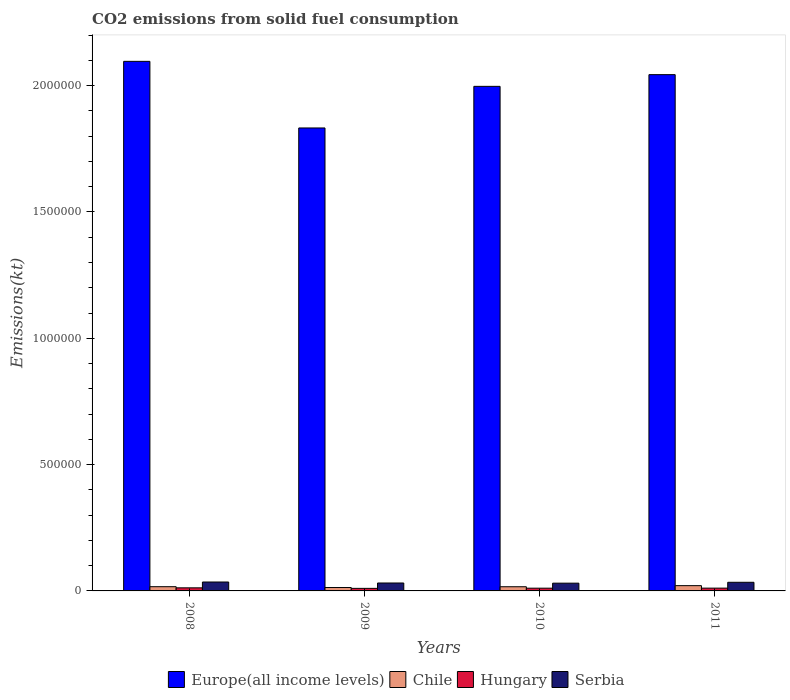How many different coloured bars are there?
Offer a very short reply. 4. How many groups of bars are there?
Ensure brevity in your answer.  4. Are the number of bars per tick equal to the number of legend labels?
Provide a short and direct response. Yes. How many bars are there on the 3rd tick from the left?
Provide a short and direct response. 4. How many bars are there on the 2nd tick from the right?
Give a very brief answer. 4. In how many cases, is the number of bars for a given year not equal to the number of legend labels?
Your response must be concise. 0. What is the amount of CO2 emitted in Chile in 2011?
Your answer should be very brief. 2.09e+04. Across all years, what is the maximum amount of CO2 emitted in Hungary?
Ensure brevity in your answer.  1.22e+04. Across all years, what is the minimum amount of CO2 emitted in Europe(all income levels)?
Offer a terse response. 1.83e+06. What is the total amount of CO2 emitted in Hungary in the graph?
Offer a very short reply. 4.41e+04. What is the difference between the amount of CO2 emitted in Serbia in 2010 and that in 2011?
Provide a succinct answer. -3501.98. What is the difference between the amount of CO2 emitted in Chile in 2010 and the amount of CO2 emitted in Hungary in 2009?
Give a very brief answer. 6461.25. What is the average amount of CO2 emitted in Hungary per year?
Offer a terse response. 1.10e+04. In the year 2009, what is the difference between the amount of CO2 emitted in Europe(all income levels) and amount of CO2 emitted in Serbia?
Keep it short and to the point. 1.80e+06. In how many years, is the amount of CO2 emitted in Chile greater than 900000 kt?
Provide a short and direct response. 0. What is the ratio of the amount of CO2 emitted in Europe(all income levels) in 2008 to that in 2010?
Make the answer very short. 1.05. Is the amount of CO2 emitted in Europe(all income levels) in 2009 less than that in 2011?
Provide a short and direct response. Yes. Is the difference between the amount of CO2 emitted in Europe(all income levels) in 2008 and 2010 greater than the difference between the amount of CO2 emitted in Serbia in 2008 and 2010?
Provide a succinct answer. Yes. What is the difference between the highest and the second highest amount of CO2 emitted in Serbia?
Your response must be concise. 1118.43. What is the difference between the highest and the lowest amount of CO2 emitted in Hungary?
Your answer should be compact. 2108.52. What does the 2nd bar from the right in 2008 represents?
Offer a terse response. Hungary. How many bars are there?
Offer a terse response. 16. How many years are there in the graph?
Your answer should be very brief. 4. What is the difference between two consecutive major ticks on the Y-axis?
Provide a succinct answer. 5.00e+05. Are the values on the major ticks of Y-axis written in scientific E-notation?
Keep it short and to the point. No. Does the graph contain grids?
Ensure brevity in your answer.  No. How many legend labels are there?
Offer a terse response. 4. What is the title of the graph?
Give a very brief answer. CO2 emissions from solid fuel consumption. What is the label or title of the Y-axis?
Your response must be concise. Emissions(kt). What is the Emissions(kt) in Europe(all income levels) in 2008?
Provide a short and direct response. 2.10e+06. What is the Emissions(kt) in Chile in 2008?
Your answer should be very brief. 1.67e+04. What is the Emissions(kt) of Hungary in 2008?
Give a very brief answer. 1.22e+04. What is the Emissions(kt) in Serbia in 2008?
Your answer should be very brief. 3.53e+04. What is the Emissions(kt) in Europe(all income levels) in 2009?
Make the answer very short. 1.83e+06. What is the Emissions(kt) in Chile in 2009?
Give a very brief answer. 1.34e+04. What is the Emissions(kt) of Hungary in 2009?
Provide a succinct answer. 1.01e+04. What is the Emissions(kt) of Serbia in 2009?
Your answer should be very brief. 3.14e+04. What is the Emissions(kt) in Europe(all income levels) in 2010?
Provide a succinct answer. 2.00e+06. What is the Emissions(kt) of Chile in 2010?
Your response must be concise. 1.65e+04. What is the Emissions(kt) in Hungary in 2010?
Your answer should be very brief. 1.08e+04. What is the Emissions(kt) of Serbia in 2010?
Your answer should be compact. 3.07e+04. What is the Emissions(kt) of Europe(all income levels) in 2011?
Offer a terse response. 2.04e+06. What is the Emissions(kt) in Chile in 2011?
Offer a very short reply. 2.09e+04. What is the Emissions(kt) of Hungary in 2011?
Offer a terse response. 1.10e+04. What is the Emissions(kt) in Serbia in 2011?
Keep it short and to the point. 3.42e+04. Across all years, what is the maximum Emissions(kt) in Europe(all income levels)?
Offer a terse response. 2.10e+06. Across all years, what is the maximum Emissions(kt) in Chile?
Your answer should be very brief. 2.09e+04. Across all years, what is the maximum Emissions(kt) of Hungary?
Provide a short and direct response. 1.22e+04. Across all years, what is the maximum Emissions(kt) in Serbia?
Your response must be concise. 3.53e+04. Across all years, what is the minimum Emissions(kt) of Europe(all income levels)?
Your answer should be very brief. 1.83e+06. Across all years, what is the minimum Emissions(kt) of Chile?
Your response must be concise. 1.34e+04. Across all years, what is the minimum Emissions(kt) of Hungary?
Offer a terse response. 1.01e+04. Across all years, what is the minimum Emissions(kt) of Serbia?
Ensure brevity in your answer.  3.07e+04. What is the total Emissions(kt) in Europe(all income levels) in the graph?
Your response must be concise. 7.97e+06. What is the total Emissions(kt) of Chile in the graph?
Give a very brief answer. 6.76e+04. What is the total Emissions(kt) of Hungary in the graph?
Keep it short and to the point. 4.41e+04. What is the total Emissions(kt) in Serbia in the graph?
Offer a very short reply. 1.32e+05. What is the difference between the Emissions(kt) of Europe(all income levels) in 2008 and that in 2009?
Your answer should be compact. 2.64e+05. What is the difference between the Emissions(kt) of Chile in 2008 and that in 2009?
Ensure brevity in your answer.  3303.97. What is the difference between the Emissions(kt) in Hungary in 2008 and that in 2009?
Offer a very short reply. 2108.53. What is the difference between the Emissions(kt) of Serbia in 2008 and that in 2009?
Make the answer very short. 3938.36. What is the difference between the Emissions(kt) of Europe(all income levels) in 2008 and that in 2010?
Provide a succinct answer. 9.89e+04. What is the difference between the Emissions(kt) of Chile in 2008 and that in 2010?
Your answer should be compact. 198.02. What is the difference between the Emissions(kt) of Hungary in 2008 and that in 2010?
Offer a terse response. 1349.46. What is the difference between the Emissions(kt) in Serbia in 2008 and that in 2010?
Make the answer very short. 4620.42. What is the difference between the Emissions(kt) in Europe(all income levels) in 2008 and that in 2011?
Give a very brief answer. 5.26e+04. What is the difference between the Emissions(kt) in Chile in 2008 and that in 2011?
Your answer should be compact. -4110.71. What is the difference between the Emissions(kt) of Hungary in 2008 and that in 2011?
Provide a succinct answer. 1180.77. What is the difference between the Emissions(kt) of Serbia in 2008 and that in 2011?
Give a very brief answer. 1118.43. What is the difference between the Emissions(kt) in Europe(all income levels) in 2009 and that in 2010?
Provide a succinct answer. -1.65e+05. What is the difference between the Emissions(kt) in Chile in 2009 and that in 2010?
Ensure brevity in your answer.  -3105.95. What is the difference between the Emissions(kt) in Hungary in 2009 and that in 2010?
Provide a succinct answer. -759.07. What is the difference between the Emissions(kt) in Serbia in 2009 and that in 2010?
Your answer should be compact. 682.06. What is the difference between the Emissions(kt) of Europe(all income levels) in 2009 and that in 2011?
Keep it short and to the point. -2.11e+05. What is the difference between the Emissions(kt) of Chile in 2009 and that in 2011?
Offer a terse response. -7414.67. What is the difference between the Emissions(kt) of Hungary in 2009 and that in 2011?
Keep it short and to the point. -927.75. What is the difference between the Emissions(kt) of Serbia in 2009 and that in 2011?
Offer a very short reply. -2819.92. What is the difference between the Emissions(kt) in Europe(all income levels) in 2010 and that in 2011?
Keep it short and to the point. -4.63e+04. What is the difference between the Emissions(kt) in Chile in 2010 and that in 2011?
Offer a terse response. -4308.73. What is the difference between the Emissions(kt) in Hungary in 2010 and that in 2011?
Give a very brief answer. -168.68. What is the difference between the Emissions(kt) of Serbia in 2010 and that in 2011?
Offer a very short reply. -3501.99. What is the difference between the Emissions(kt) of Europe(all income levels) in 2008 and the Emissions(kt) of Chile in 2009?
Your answer should be compact. 2.08e+06. What is the difference between the Emissions(kt) in Europe(all income levels) in 2008 and the Emissions(kt) in Hungary in 2009?
Your answer should be compact. 2.09e+06. What is the difference between the Emissions(kt) in Europe(all income levels) in 2008 and the Emissions(kt) in Serbia in 2009?
Make the answer very short. 2.06e+06. What is the difference between the Emissions(kt) of Chile in 2008 and the Emissions(kt) of Hungary in 2009?
Make the answer very short. 6659.27. What is the difference between the Emissions(kt) in Chile in 2008 and the Emissions(kt) in Serbia in 2009?
Ensure brevity in your answer.  -1.46e+04. What is the difference between the Emissions(kt) in Hungary in 2008 and the Emissions(kt) in Serbia in 2009?
Offer a terse response. -1.92e+04. What is the difference between the Emissions(kt) in Europe(all income levels) in 2008 and the Emissions(kt) in Chile in 2010?
Your answer should be compact. 2.08e+06. What is the difference between the Emissions(kt) of Europe(all income levels) in 2008 and the Emissions(kt) of Hungary in 2010?
Make the answer very short. 2.09e+06. What is the difference between the Emissions(kt) of Europe(all income levels) in 2008 and the Emissions(kt) of Serbia in 2010?
Offer a very short reply. 2.07e+06. What is the difference between the Emissions(kt) in Chile in 2008 and the Emissions(kt) in Hungary in 2010?
Your response must be concise. 5900.2. What is the difference between the Emissions(kt) of Chile in 2008 and the Emissions(kt) of Serbia in 2010?
Your response must be concise. -1.39e+04. What is the difference between the Emissions(kt) in Hungary in 2008 and the Emissions(kt) in Serbia in 2010?
Your answer should be very brief. -1.85e+04. What is the difference between the Emissions(kt) in Europe(all income levels) in 2008 and the Emissions(kt) in Chile in 2011?
Give a very brief answer. 2.08e+06. What is the difference between the Emissions(kt) in Europe(all income levels) in 2008 and the Emissions(kt) in Hungary in 2011?
Ensure brevity in your answer.  2.09e+06. What is the difference between the Emissions(kt) of Europe(all income levels) in 2008 and the Emissions(kt) of Serbia in 2011?
Keep it short and to the point. 2.06e+06. What is the difference between the Emissions(kt) of Chile in 2008 and the Emissions(kt) of Hungary in 2011?
Your response must be concise. 5731.52. What is the difference between the Emissions(kt) of Chile in 2008 and the Emissions(kt) of Serbia in 2011?
Ensure brevity in your answer.  -1.74e+04. What is the difference between the Emissions(kt) of Hungary in 2008 and the Emissions(kt) of Serbia in 2011?
Provide a short and direct response. -2.20e+04. What is the difference between the Emissions(kt) of Europe(all income levels) in 2009 and the Emissions(kt) of Chile in 2010?
Ensure brevity in your answer.  1.82e+06. What is the difference between the Emissions(kt) of Europe(all income levels) in 2009 and the Emissions(kt) of Hungary in 2010?
Your answer should be compact. 1.82e+06. What is the difference between the Emissions(kt) of Europe(all income levels) in 2009 and the Emissions(kt) of Serbia in 2010?
Ensure brevity in your answer.  1.80e+06. What is the difference between the Emissions(kt) in Chile in 2009 and the Emissions(kt) in Hungary in 2010?
Give a very brief answer. 2596.24. What is the difference between the Emissions(kt) in Chile in 2009 and the Emissions(kt) in Serbia in 2010?
Make the answer very short. -1.72e+04. What is the difference between the Emissions(kt) in Hungary in 2009 and the Emissions(kt) in Serbia in 2010?
Make the answer very short. -2.06e+04. What is the difference between the Emissions(kt) of Europe(all income levels) in 2009 and the Emissions(kt) of Chile in 2011?
Make the answer very short. 1.81e+06. What is the difference between the Emissions(kt) of Europe(all income levels) in 2009 and the Emissions(kt) of Hungary in 2011?
Give a very brief answer. 1.82e+06. What is the difference between the Emissions(kt) in Europe(all income levels) in 2009 and the Emissions(kt) in Serbia in 2011?
Provide a succinct answer. 1.80e+06. What is the difference between the Emissions(kt) of Chile in 2009 and the Emissions(kt) of Hungary in 2011?
Provide a succinct answer. 2427.55. What is the difference between the Emissions(kt) in Chile in 2009 and the Emissions(kt) in Serbia in 2011?
Your answer should be very brief. -2.07e+04. What is the difference between the Emissions(kt) in Hungary in 2009 and the Emissions(kt) in Serbia in 2011?
Your response must be concise. -2.41e+04. What is the difference between the Emissions(kt) of Europe(all income levels) in 2010 and the Emissions(kt) of Chile in 2011?
Make the answer very short. 1.98e+06. What is the difference between the Emissions(kt) of Europe(all income levels) in 2010 and the Emissions(kt) of Hungary in 2011?
Offer a very short reply. 1.99e+06. What is the difference between the Emissions(kt) of Europe(all income levels) in 2010 and the Emissions(kt) of Serbia in 2011?
Give a very brief answer. 1.96e+06. What is the difference between the Emissions(kt) of Chile in 2010 and the Emissions(kt) of Hungary in 2011?
Provide a succinct answer. 5533.5. What is the difference between the Emissions(kt) in Chile in 2010 and the Emissions(kt) in Serbia in 2011?
Your answer should be very brief. -1.76e+04. What is the difference between the Emissions(kt) of Hungary in 2010 and the Emissions(kt) of Serbia in 2011?
Make the answer very short. -2.33e+04. What is the average Emissions(kt) in Europe(all income levels) per year?
Offer a terse response. 1.99e+06. What is the average Emissions(kt) of Chile per year?
Offer a terse response. 1.69e+04. What is the average Emissions(kt) in Hungary per year?
Your response must be concise. 1.10e+04. What is the average Emissions(kt) of Serbia per year?
Your response must be concise. 3.29e+04. In the year 2008, what is the difference between the Emissions(kt) in Europe(all income levels) and Emissions(kt) in Chile?
Provide a succinct answer. 2.08e+06. In the year 2008, what is the difference between the Emissions(kt) in Europe(all income levels) and Emissions(kt) in Hungary?
Offer a very short reply. 2.08e+06. In the year 2008, what is the difference between the Emissions(kt) in Europe(all income levels) and Emissions(kt) in Serbia?
Offer a very short reply. 2.06e+06. In the year 2008, what is the difference between the Emissions(kt) in Chile and Emissions(kt) in Hungary?
Keep it short and to the point. 4550.75. In the year 2008, what is the difference between the Emissions(kt) of Chile and Emissions(kt) of Serbia?
Offer a terse response. -1.86e+04. In the year 2008, what is the difference between the Emissions(kt) in Hungary and Emissions(kt) in Serbia?
Offer a terse response. -2.31e+04. In the year 2009, what is the difference between the Emissions(kt) of Europe(all income levels) and Emissions(kt) of Chile?
Your answer should be very brief. 1.82e+06. In the year 2009, what is the difference between the Emissions(kt) in Europe(all income levels) and Emissions(kt) in Hungary?
Give a very brief answer. 1.82e+06. In the year 2009, what is the difference between the Emissions(kt) of Europe(all income levels) and Emissions(kt) of Serbia?
Your response must be concise. 1.80e+06. In the year 2009, what is the difference between the Emissions(kt) in Chile and Emissions(kt) in Hungary?
Offer a terse response. 3355.3. In the year 2009, what is the difference between the Emissions(kt) in Chile and Emissions(kt) in Serbia?
Provide a succinct answer. -1.79e+04. In the year 2009, what is the difference between the Emissions(kt) of Hungary and Emissions(kt) of Serbia?
Offer a terse response. -2.13e+04. In the year 2010, what is the difference between the Emissions(kt) of Europe(all income levels) and Emissions(kt) of Chile?
Your answer should be very brief. 1.98e+06. In the year 2010, what is the difference between the Emissions(kt) in Europe(all income levels) and Emissions(kt) in Hungary?
Keep it short and to the point. 1.99e+06. In the year 2010, what is the difference between the Emissions(kt) of Europe(all income levels) and Emissions(kt) of Serbia?
Keep it short and to the point. 1.97e+06. In the year 2010, what is the difference between the Emissions(kt) of Chile and Emissions(kt) of Hungary?
Your answer should be compact. 5702.19. In the year 2010, what is the difference between the Emissions(kt) of Chile and Emissions(kt) of Serbia?
Ensure brevity in your answer.  -1.41e+04. In the year 2010, what is the difference between the Emissions(kt) of Hungary and Emissions(kt) of Serbia?
Offer a very short reply. -1.98e+04. In the year 2011, what is the difference between the Emissions(kt) in Europe(all income levels) and Emissions(kt) in Chile?
Offer a very short reply. 2.02e+06. In the year 2011, what is the difference between the Emissions(kt) of Europe(all income levels) and Emissions(kt) of Hungary?
Give a very brief answer. 2.03e+06. In the year 2011, what is the difference between the Emissions(kt) of Europe(all income levels) and Emissions(kt) of Serbia?
Give a very brief answer. 2.01e+06. In the year 2011, what is the difference between the Emissions(kt) of Chile and Emissions(kt) of Hungary?
Your answer should be very brief. 9842.23. In the year 2011, what is the difference between the Emissions(kt) of Chile and Emissions(kt) of Serbia?
Make the answer very short. -1.33e+04. In the year 2011, what is the difference between the Emissions(kt) of Hungary and Emissions(kt) of Serbia?
Ensure brevity in your answer.  -2.32e+04. What is the ratio of the Emissions(kt) of Europe(all income levels) in 2008 to that in 2009?
Your answer should be very brief. 1.14. What is the ratio of the Emissions(kt) in Chile in 2008 to that in 2009?
Provide a succinct answer. 1.25. What is the ratio of the Emissions(kt) of Hungary in 2008 to that in 2009?
Ensure brevity in your answer.  1.21. What is the ratio of the Emissions(kt) in Serbia in 2008 to that in 2009?
Make the answer very short. 1.13. What is the ratio of the Emissions(kt) in Europe(all income levels) in 2008 to that in 2010?
Give a very brief answer. 1.05. What is the ratio of the Emissions(kt) in Chile in 2008 to that in 2010?
Your response must be concise. 1.01. What is the ratio of the Emissions(kt) in Hungary in 2008 to that in 2010?
Your answer should be very brief. 1.12. What is the ratio of the Emissions(kt) in Serbia in 2008 to that in 2010?
Provide a succinct answer. 1.15. What is the ratio of the Emissions(kt) of Europe(all income levels) in 2008 to that in 2011?
Make the answer very short. 1.03. What is the ratio of the Emissions(kt) in Chile in 2008 to that in 2011?
Ensure brevity in your answer.  0.8. What is the ratio of the Emissions(kt) of Hungary in 2008 to that in 2011?
Offer a terse response. 1.11. What is the ratio of the Emissions(kt) in Serbia in 2008 to that in 2011?
Offer a very short reply. 1.03. What is the ratio of the Emissions(kt) in Europe(all income levels) in 2009 to that in 2010?
Offer a terse response. 0.92. What is the ratio of the Emissions(kt) of Chile in 2009 to that in 2010?
Your answer should be very brief. 0.81. What is the ratio of the Emissions(kt) in Hungary in 2009 to that in 2010?
Ensure brevity in your answer.  0.93. What is the ratio of the Emissions(kt) in Serbia in 2009 to that in 2010?
Make the answer very short. 1.02. What is the ratio of the Emissions(kt) in Europe(all income levels) in 2009 to that in 2011?
Your response must be concise. 0.9. What is the ratio of the Emissions(kt) in Chile in 2009 to that in 2011?
Ensure brevity in your answer.  0.64. What is the ratio of the Emissions(kt) of Hungary in 2009 to that in 2011?
Keep it short and to the point. 0.92. What is the ratio of the Emissions(kt) of Serbia in 2009 to that in 2011?
Offer a very short reply. 0.92. What is the ratio of the Emissions(kt) of Europe(all income levels) in 2010 to that in 2011?
Provide a short and direct response. 0.98. What is the ratio of the Emissions(kt) of Chile in 2010 to that in 2011?
Your answer should be compact. 0.79. What is the ratio of the Emissions(kt) of Hungary in 2010 to that in 2011?
Keep it short and to the point. 0.98. What is the ratio of the Emissions(kt) of Serbia in 2010 to that in 2011?
Your answer should be very brief. 0.9. What is the difference between the highest and the second highest Emissions(kt) of Europe(all income levels)?
Ensure brevity in your answer.  5.26e+04. What is the difference between the highest and the second highest Emissions(kt) of Chile?
Make the answer very short. 4110.71. What is the difference between the highest and the second highest Emissions(kt) of Hungary?
Provide a succinct answer. 1180.77. What is the difference between the highest and the second highest Emissions(kt) of Serbia?
Your answer should be very brief. 1118.43. What is the difference between the highest and the lowest Emissions(kt) in Europe(all income levels)?
Offer a terse response. 2.64e+05. What is the difference between the highest and the lowest Emissions(kt) of Chile?
Provide a short and direct response. 7414.67. What is the difference between the highest and the lowest Emissions(kt) in Hungary?
Make the answer very short. 2108.53. What is the difference between the highest and the lowest Emissions(kt) in Serbia?
Offer a very short reply. 4620.42. 